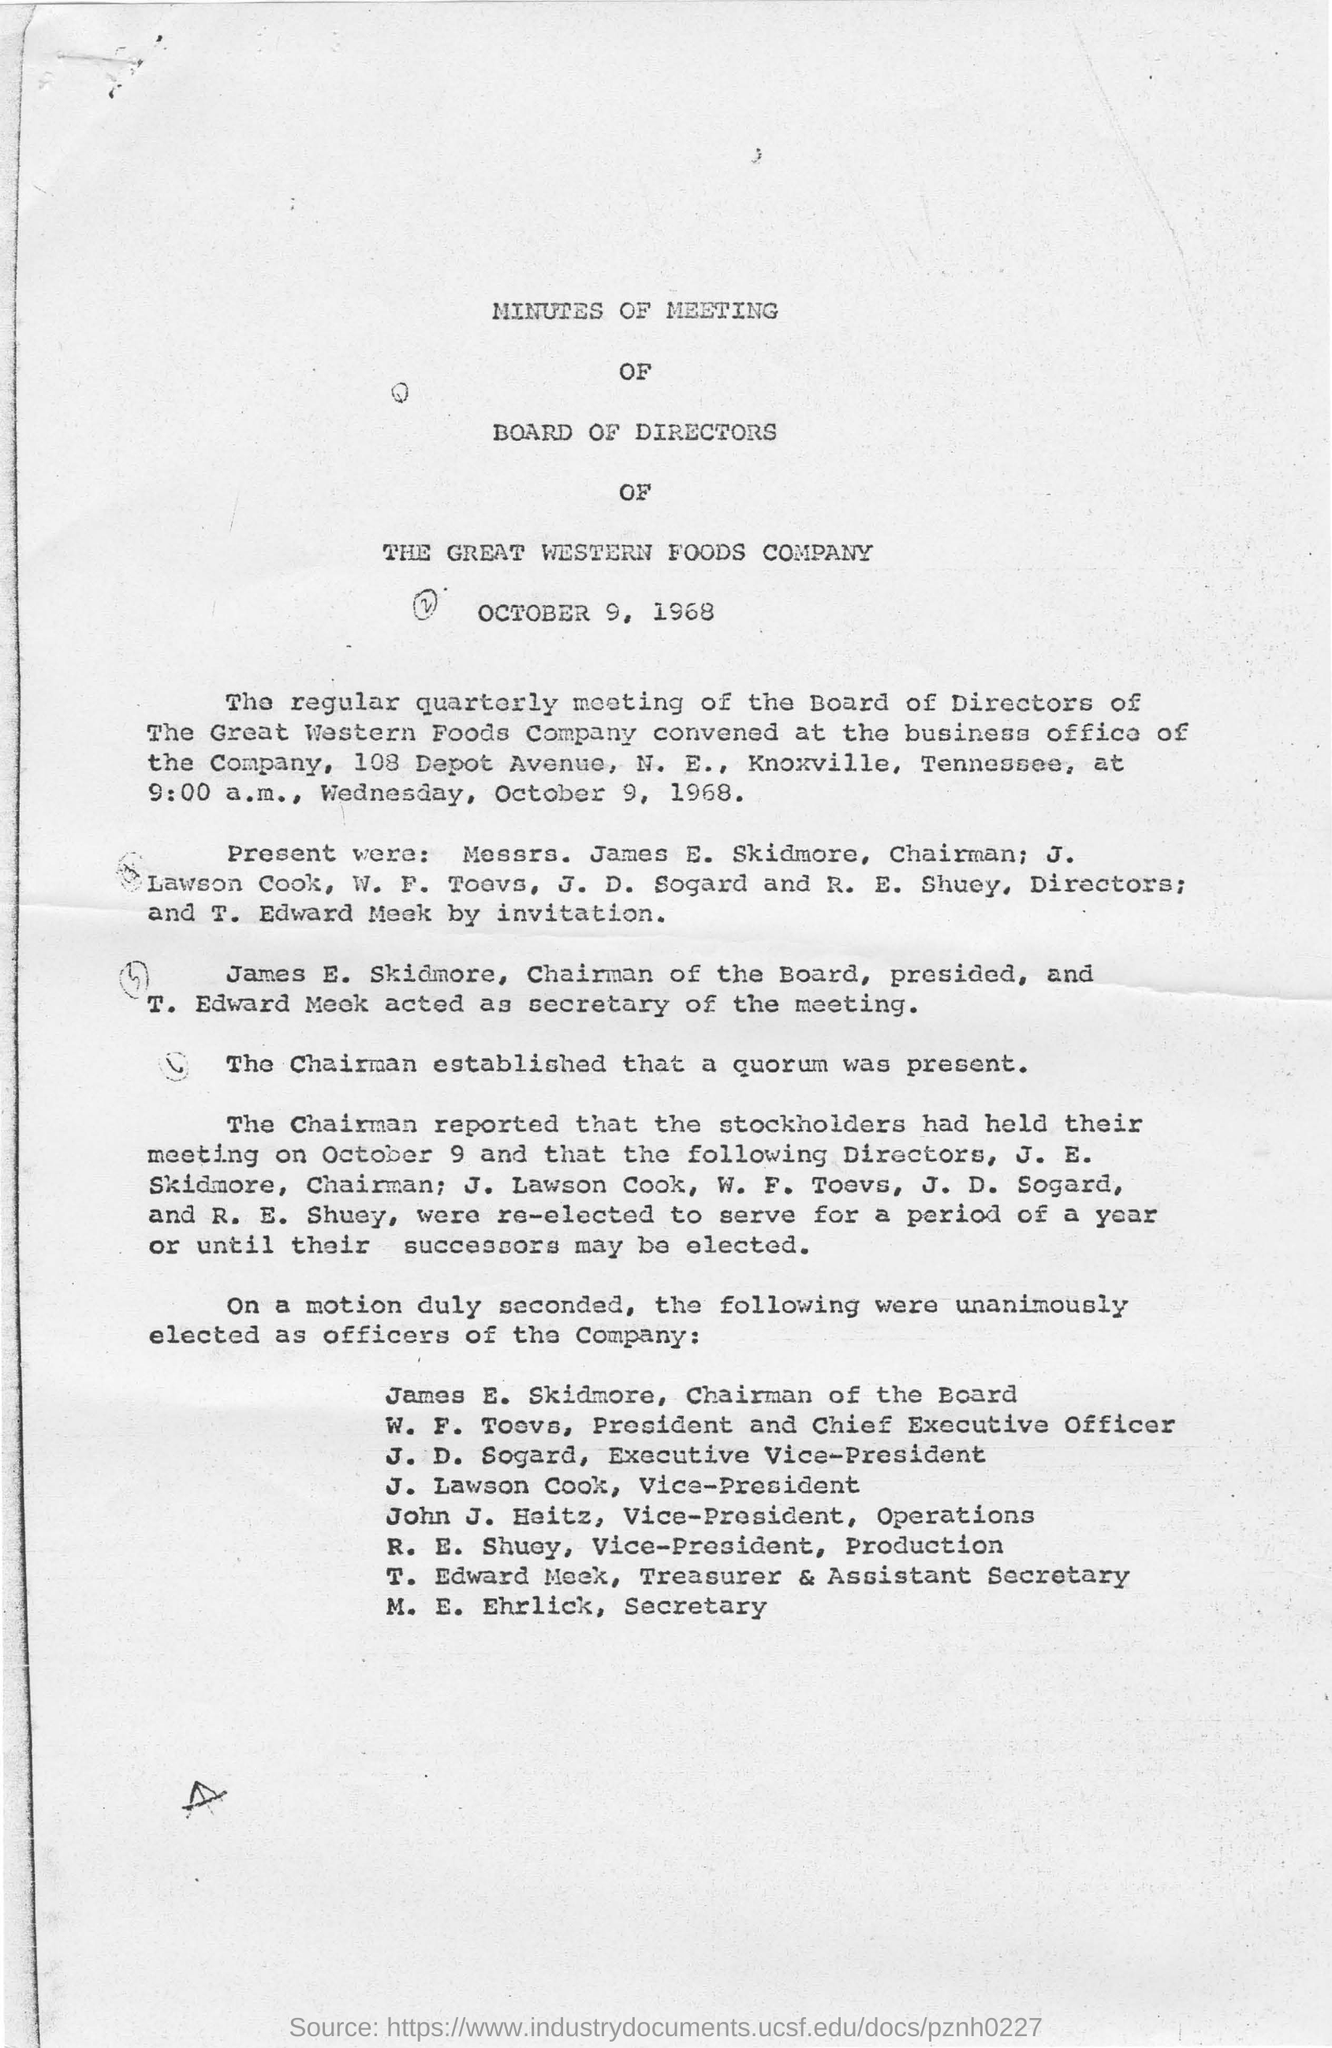Specify some key components in this picture. The chairman of the board is James E. Skidmore, who was unanimously elected by the board members. The speaker is inquiring who is the secretary of the meeting, and the answer provided is "T. Edward Meek. The regular board of directors of the Great Western Foods Company was convened at the business office of the company. The secretary is unanimously elected, and their name is M.E. EHRLICK. The vice president, J. Lawson Cook, is unanimously elected. 